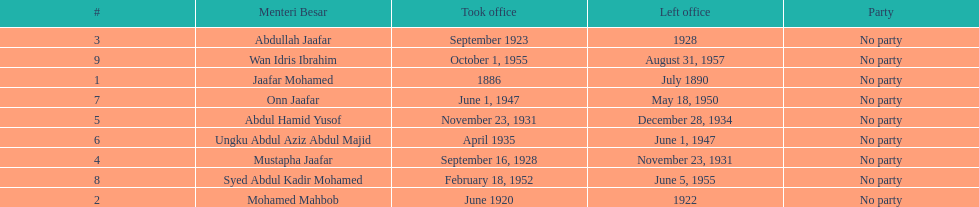Who was in office after mustapha jaafar Abdul Hamid Yusof. 